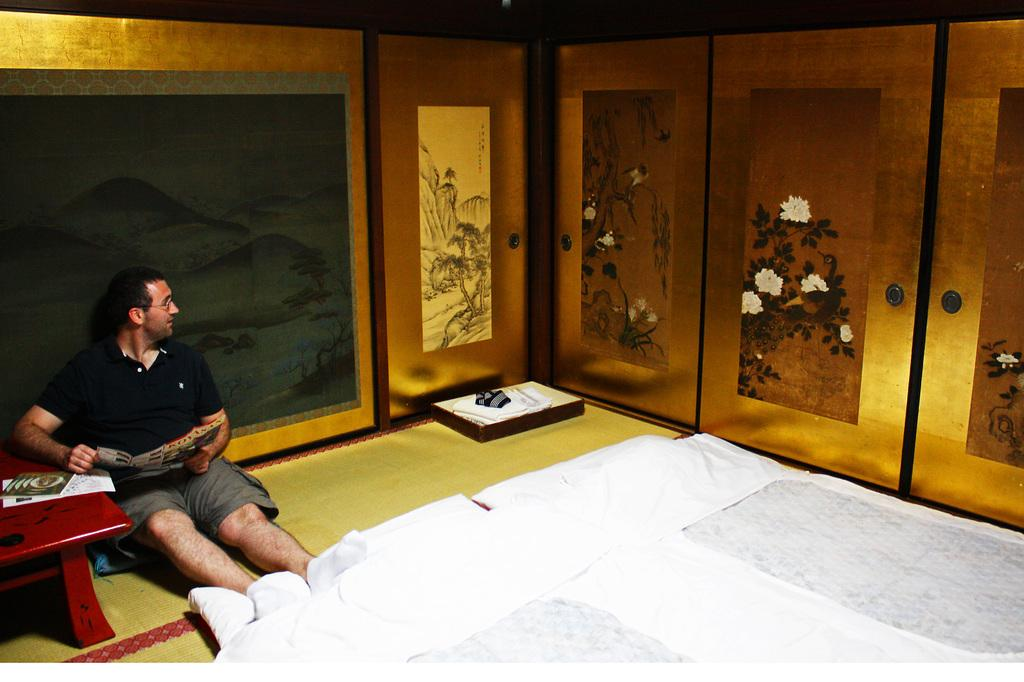What is the man in the image doing? The man is sitting on the floor in the image. What object can be seen in the image besides the man? There is a table in the image. What is on the table in the image? There is a book on the table in the image. What is visible in the background of the image? There is a wall in the image. What type of beam is the man using to bite his hands in the image? There is no beam or biting of hands present in the image; the man is simply sitting on the floor. 